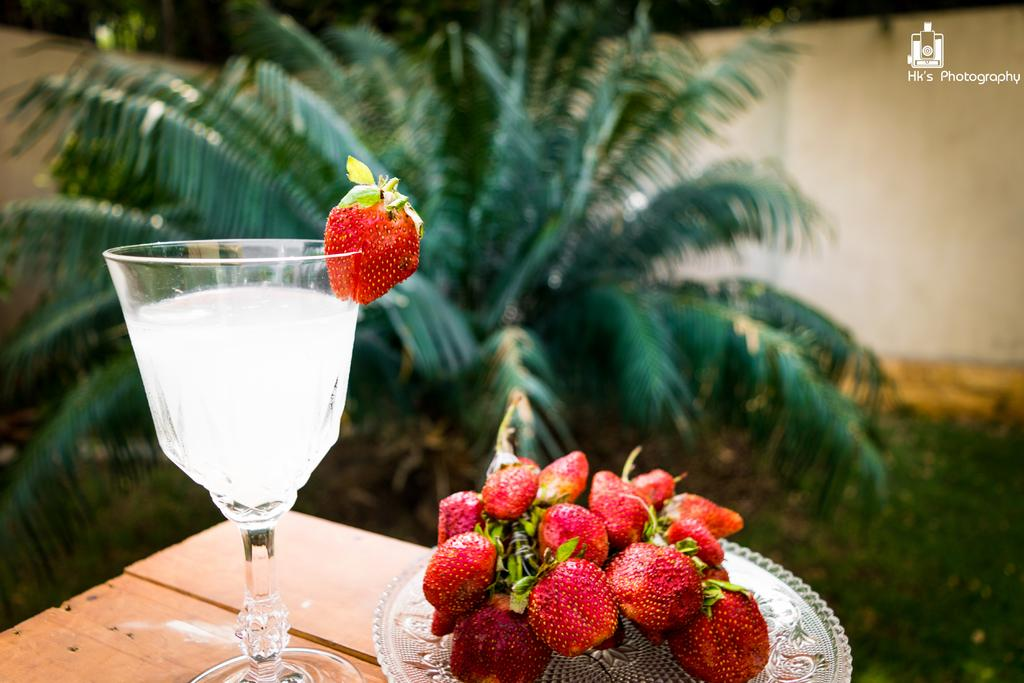What is in the juice glass that is visible in the image? There is a juice glass with a strawberry in the image. What other items related to strawberries can be seen in the image? There are strawberries placed on a plate in the image. Where is the plate with strawberries located? The plate with strawberries is on a wooden table. How many cacti are present on the wooden table in the image? There are no cacti present on the wooden table in the image; it only contains a plate with strawberries. 